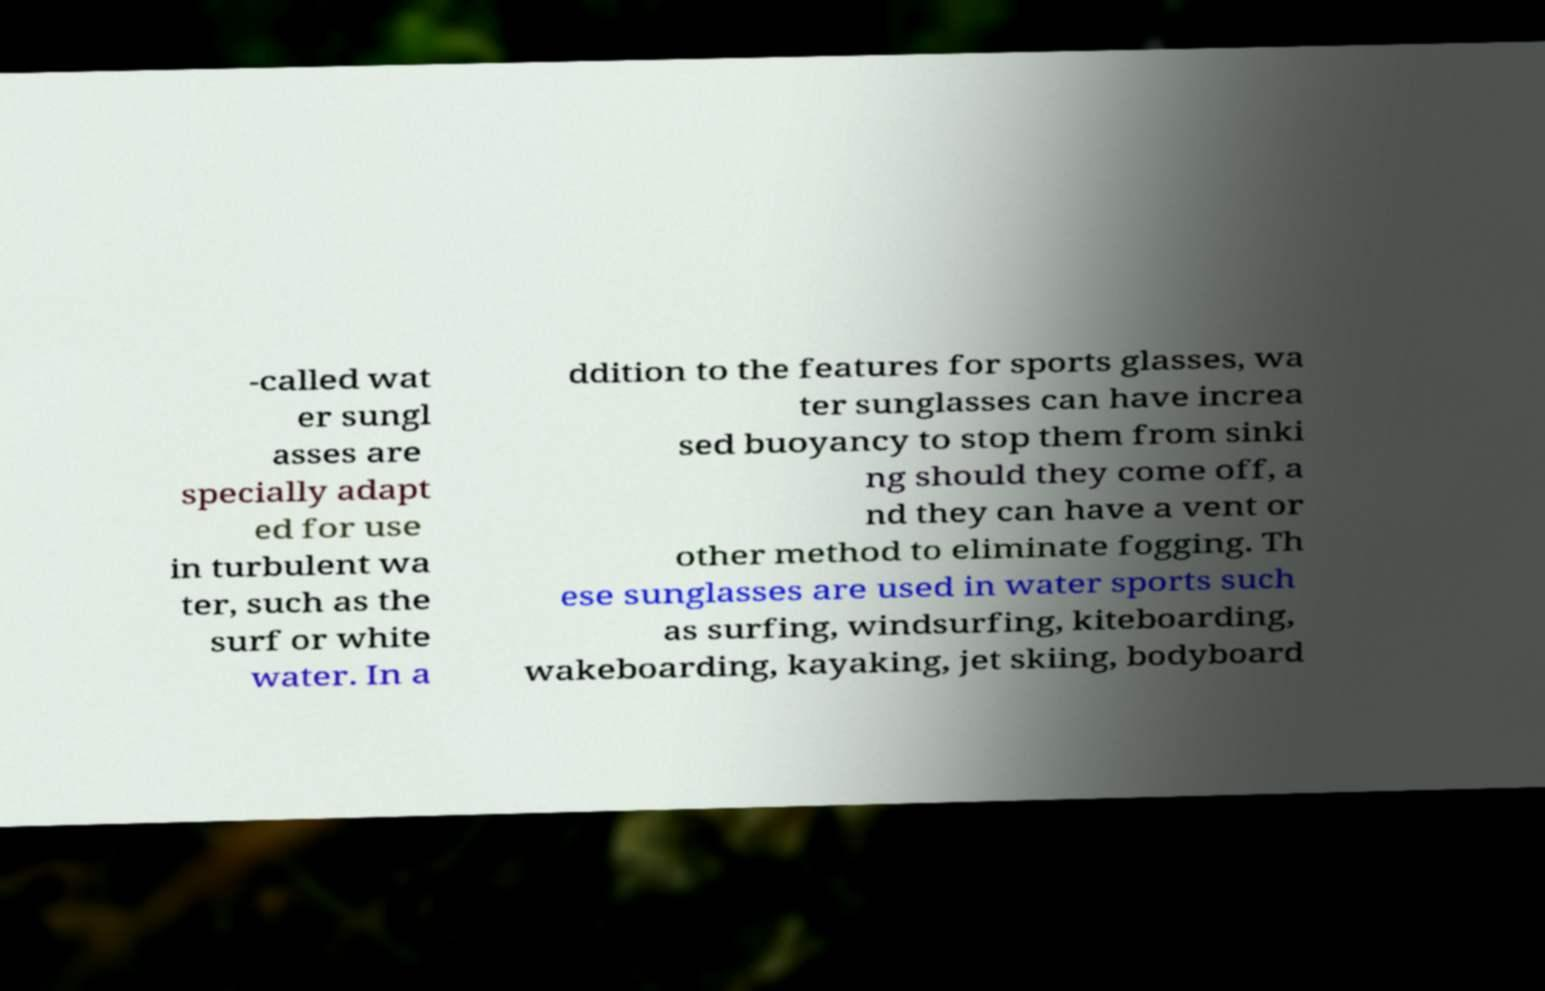Please identify and transcribe the text found in this image. -called wat er sungl asses are specially adapt ed for use in turbulent wa ter, such as the surf or white water. In a ddition to the features for sports glasses, wa ter sunglasses can have increa sed buoyancy to stop them from sinki ng should they come off, a nd they can have a vent or other method to eliminate fogging. Th ese sunglasses are used in water sports such as surfing, windsurfing, kiteboarding, wakeboarding, kayaking, jet skiing, bodyboard 